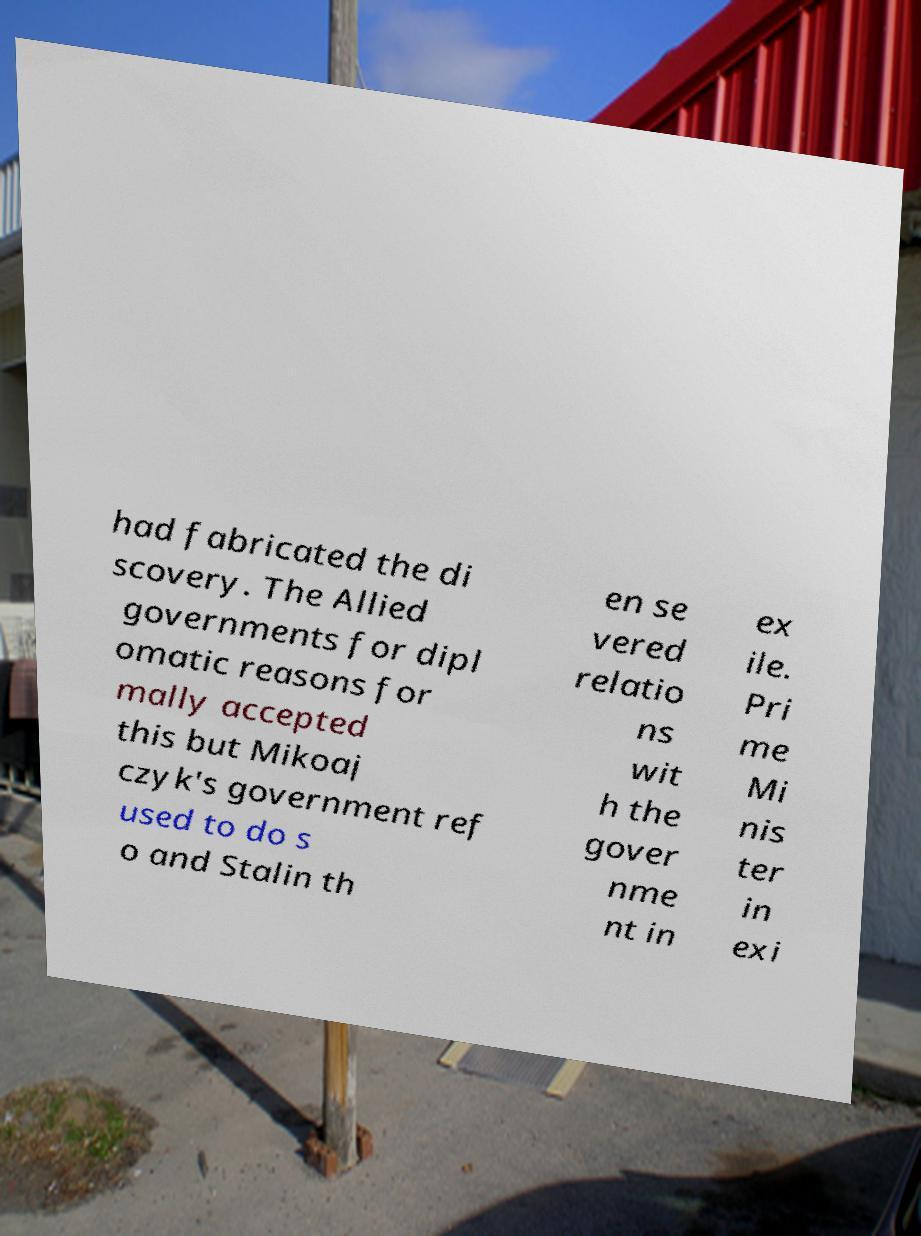Can you read and provide the text displayed in the image?This photo seems to have some interesting text. Can you extract and type it out for me? had fabricated the di scovery. The Allied governments for dipl omatic reasons for mally accepted this but Mikoaj czyk's government ref used to do s o and Stalin th en se vered relatio ns wit h the gover nme nt in ex ile. Pri me Mi nis ter in exi 